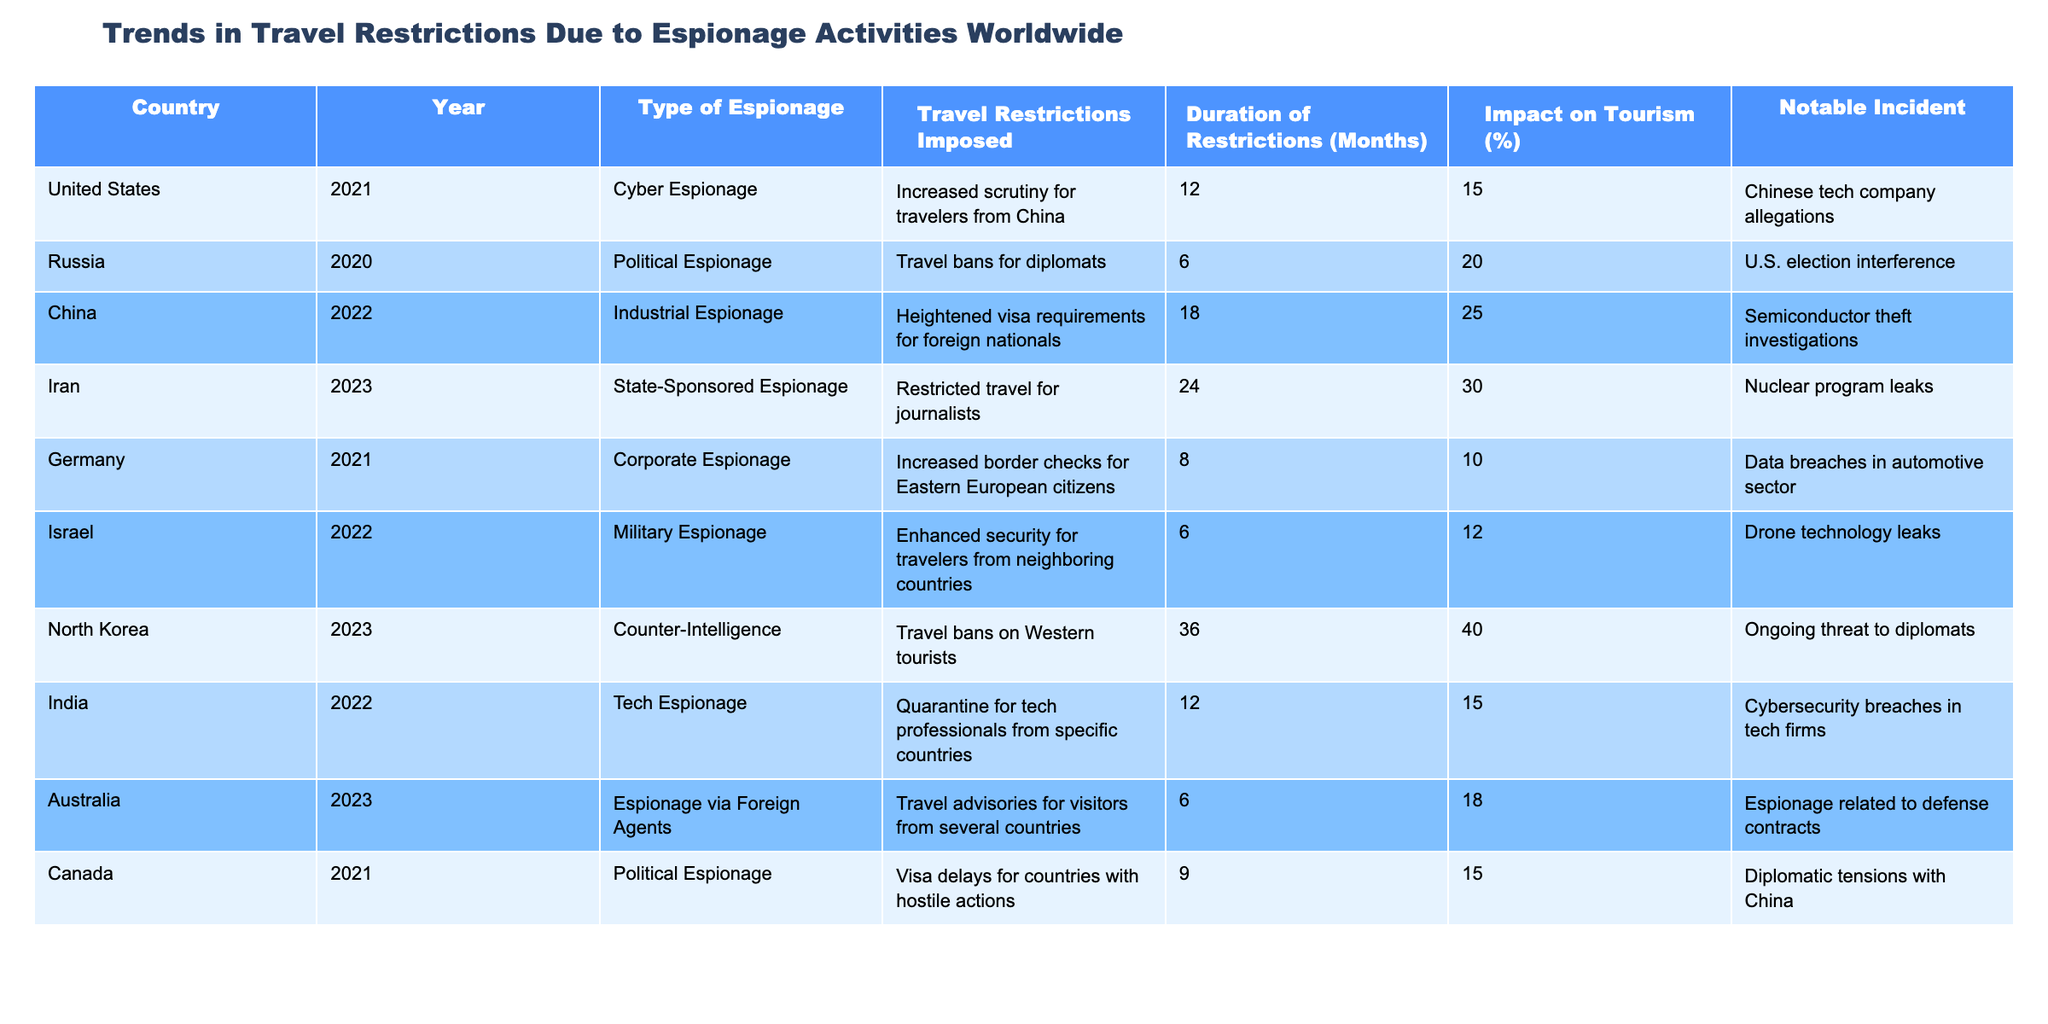What country had the longest duration of travel restrictions due to espionage activities? In the table, I can see that North Korea had travel bans on Western tourists for a duration of 36 months, which is the highest compared to other countries listed.
Answer: North Korea Which type of espionage resulted in the highest impact on tourism percentage? When reviewing the impact percentages, Iran's state-sponsored espionage led to a 30% decline in tourism, which is the highest among all types listed in the table.
Answer: State-Sponsored Espionage (Iran) How many countries had travel restrictions that lasted more than 12 months? To find this, I can look through the duration of restrictions: North Korea (36 months), Iran (24 months), and China (18 months). This totals three countries with restrictions longer than 12 months.
Answer: 3 Was there a travel ban for Western tourists in any country mentioned? Yes, according to the table, North Korea had a travel ban on Western tourists.
Answer: Yes What is the average duration of travel restrictions across all countries listed? To find the average, I sum the durations (12 + 6 + 18 + 24 + 8 + 6 + 36 + 12 + 6 + 9 =  141) and then divide by the number of countries (10). Therefore, 141 divided by 10 equals 14.1 months.
Answer: 14.1 months Which two types of espionage resulted in travel restrictions of 18 months or more? By examining the table, I see that China (industrial espionage with 18 months) and Iran (state-sponsored espionage with 24 months) both had restrictions lasting 18 months or more.
Answer: Industrial Espionage (China) and State-Sponsored Espionage (Iran) In which year did Germany impose corporate espionage-related travel restrictions? The table indicates that Germany imposed corporate espionage-related travel restrictions in the year 2021.
Answer: 2021 What is the difference in the impact on tourism between restrictions from North Korea and those from Iran? North Korea’s impact on tourism is 40%, while Iran’s is 30%. The difference is 40% - 30% = 10%.
Answer: 10% 